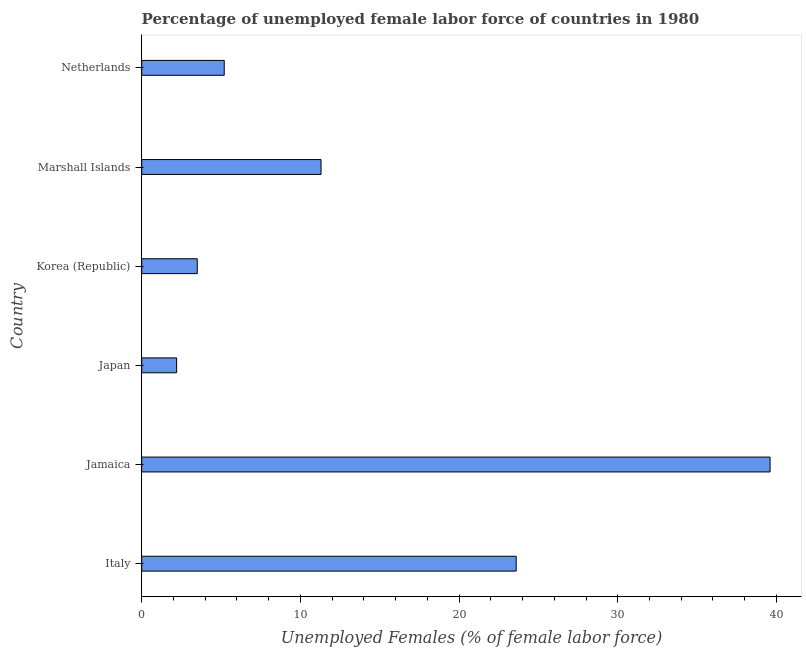What is the title of the graph?
Your answer should be very brief. Percentage of unemployed female labor force of countries in 1980. What is the label or title of the X-axis?
Provide a succinct answer. Unemployed Females (% of female labor force). What is the label or title of the Y-axis?
Offer a terse response. Country. What is the total unemployed female labour force in Marshall Islands?
Keep it short and to the point. 11.3. Across all countries, what is the maximum total unemployed female labour force?
Provide a short and direct response. 39.6. Across all countries, what is the minimum total unemployed female labour force?
Ensure brevity in your answer.  2.2. In which country was the total unemployed female labour force maximum?
Your answer should be very brief. Jamaica. In which country was the total unemployed female labour force minimum?
Make the answer very short. Japan. What is the sum of the total unemployed female labour force?
Offer a terse response. 85.4. What is the average total unemployed female labour force per country?
Ensure brevity in your answer.  14.23. What is the median total unemployed female labour force?
Offer a terse response. 8.25. What is the ratio of the total unemployed female labour force in Jamaica to that in Korea (Republic)?
Provide a short and direct response. 11.31. Is the total unemployed female labour force in Jamaica less than that in Marshall Islands?
Ensure brevity in your answer.  No. Is the difference between the total unemployed female labour force in Korea (Republic) and Netherlands greater than the difference between any two countries?
Make the answer very short. No. What is the difference between the highest and the second highest total unemployed female labour force?
Your answer should be very brief. 16. What is the difference between the highest and the lowest total unemployed female labour force?
Ensure brevity in your answer.  37.4. In how many countries, is the total unemployed female labour force greater than the average total unemployed female labour force taken over all countries?
Keep it short and to the point. 2. How many bars are there?
Give a very brief answer. 6. Are the values on the major ticks of X-axis written in scientific E-notation?
Keep it short and to the point. No. What is the Unemployed Females (% of female labor force) in Italy?
Provide a succinct answer. 23.6. What is the Unemployed Females (% of female labor force) in Jamaica?
Offer a very short reply. 39.6. What is the Unemployed Females (% of female labor force) in Japan?
Your response must be concise. 2.2. What is the Unemployed Females (% of female labor force) of Marshall Islands?
Provide a short and direct response. 11.3. What is the Unemployed Females (% of female labor force) of Netherlands?
Your answer should be very brief. 5.2. What is the difference between the Unemployed Females (% of female labor force) in Italy and Jamaica?
Ensure brevity in your answer.  -16. What is the difference between the Unemployed Females (% of female labor force) in Italy and Japan?
Keep it short and to the point. 21.4. What is the difference between the Unemployed Females (% of female labor force) in Italy and Korea (Republic)?
Provide a short and direct response. 20.1. What is the difference between the Unemployed Females (% of female labor force) in Italy and Netherlands?
Provide a short and direct response. 18.4. What is the difference between the Unemployed Females (% of female labor force) in Jamaica and Japan?
Offer a very short reply. 37.4. What is the difference between the Unemployed Females (% of female labor force) in Jamaica and Korea (Republic)?
Your answer should be compact. 36.1. What is the difference between the Unemployed Females (% of female labor force) in Jamaica and Marshall Islands?
Offer a very short reply. 28.3. What is the difference between the Unemployed Females (% of female labor force) in Jamaica and Netherlands?
Offer a very short reply. 34.4. What is the difference between the Unemployed Females (% of female labor force) in Japan and Netherlands?
Ensure brevity in your answer.  -3. What is the difference between the Unemployed Females (% of female labor force) in Korea (Republic) and Marshall Islands?
Offer a terse response. -7.8. What is the difference between the Unemployed Females (% of female labor force) in Marshall Islands and Netherlands?
Your answer should be very brief. 6.1. What is the ratio of the Unemployed Females (% of female labor force) in Italy to that in Jamaica?
Provide a succinct answer. 0.6. What is the ratio of the Unemployed Females (% of female labor force) in Italy to that in Japan?
Offer a terse response. 10.73. What is the ratio of the Unemployed Females (% of female labor force) in Italy to that in Korea (Republic)?
Make the answer very short. 6.74. What is the ratio of the Unemployed Females (% of female labor force) in Italy to that in Marshall Islands?
Make the answer very short. 2.09. What is the ratio of the Unemployed Females (% of female labor force) in Italy to that in Netherlands?
Give a very brief answer. 4.54. What is the ratio of the Unemployed Females (% of female labor force) in Jamaica to that in Korea (Republic)?
Your answer should be very brief. 11.31. What is the ratio of the Unemployed Females (% of female labor force) in Jamaica to that in Marshall Islands?
Offer a terse response. 3.5. What is the ratio of the Unemployed Females (% of female labor force) in Jamaica to that in Netherlands?
Offer a very short reply. 7.62. What is the ratio of the Unemployed Females (% of female labor force) in Japan to that in Korea (Republic)?
Provide a short and direct response. 0.63. What is the ratio of the Unemployed Females (% of female labor force) in Japan to that in Marshall Islands?
Offer a very short reply. 0.2. What is the ratio of the Unemployed Females (% of female labor force) in Japan to that in Netherlands?
Ensure brevity in your answer.  0.42. What is the ratio of the Unemployed Females (% of female labor force) in Korea (Republic) to that in Marshall Islands?
Make the answer very short. 0.31. What is the ratio of the Unemployed Females (% of female labor force) in Korea (Republic) to that in Netherlands?
Your answer should be compact. 0.67. What is the ratio of the Unemployed Females (% of female labor force) in Marshall Islands to that in Netherlands?
Keep it short and to the point. 2.17. 